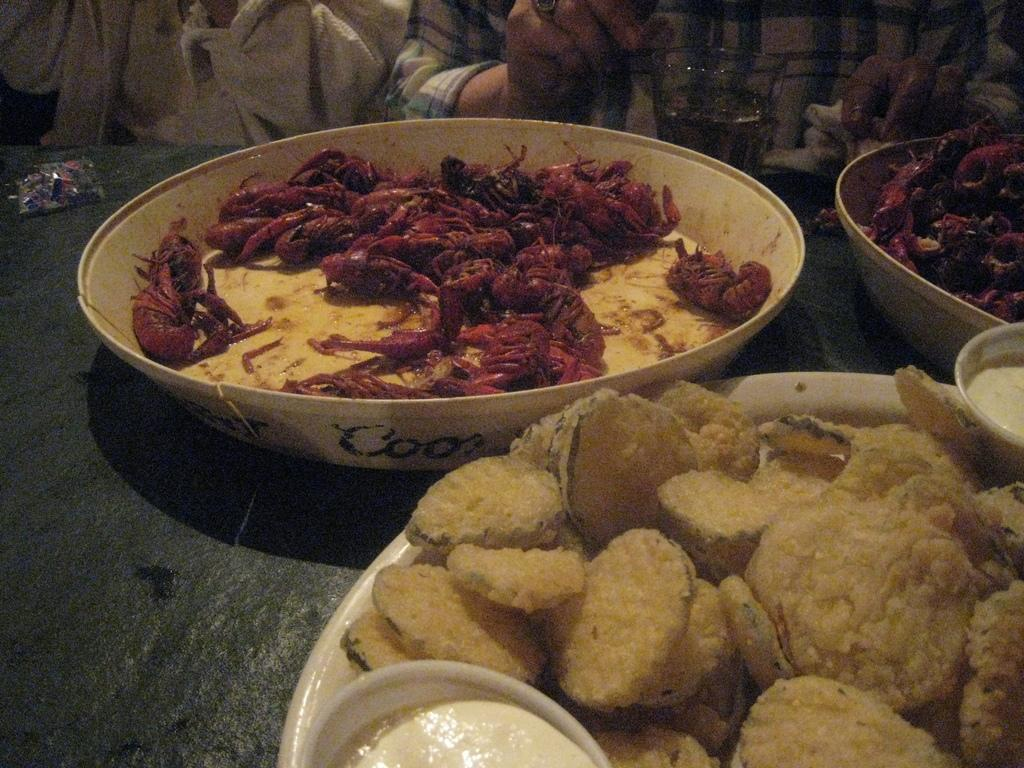What is in the bowl on the table in the image? There are food items in a bowl on a table in the image. What else can be seen on the table? There is a glass on the table. Can you describe the people in the background of the image? There are two persons in the background of the image. What sign is the girl holding in the image? There is no girl present in the image, and therefore no sign can be observed. 